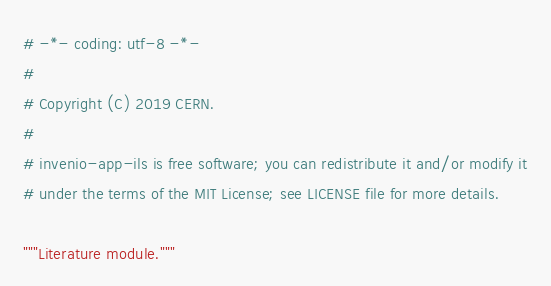<code> <loc_0><loc_0><loc_500><loc_500><_Python_># -*- coding: utf-8 -*-
#
# Copyright (C) 2019 CERN.
#
# invenio-app-ils is free software; you can redistribute it and/or modify it
# under the terms of the MIT License; see LICENSE file for more details.

"""Literature module."""
</code> 